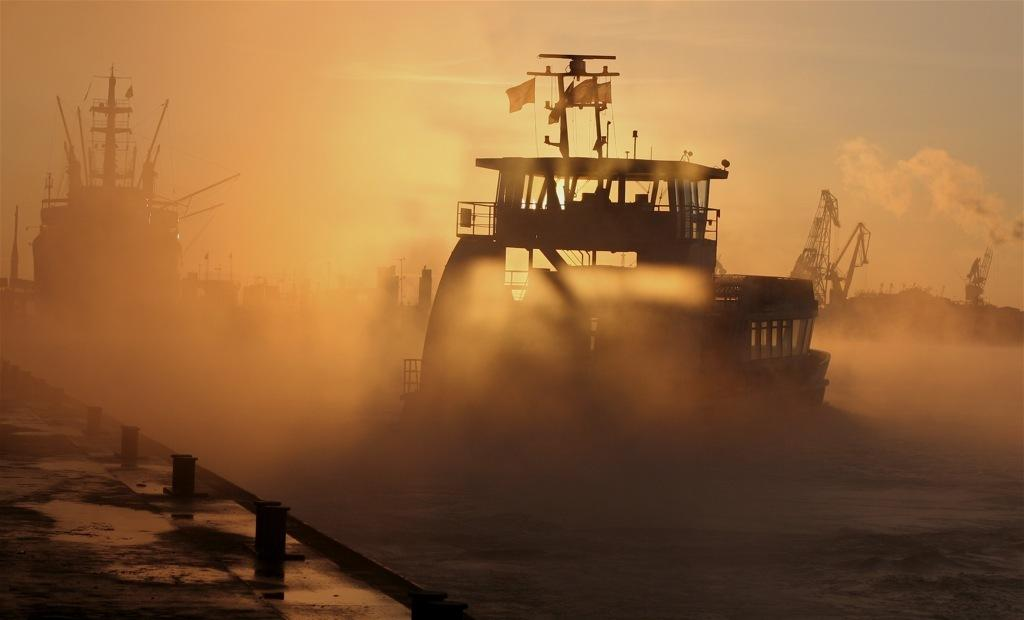What is the main subject of the image? The main subject of the image is ships on the water. What else can be seen in the image besides the ships? Flags are visible in the image, as well as mountains and the sky. What is the condition of the sky in the image? The sky is visible in the background of the image, and clouds are present. What grade is the chalk used for writing on the word in the image? There is no chalk or word present in the image. 